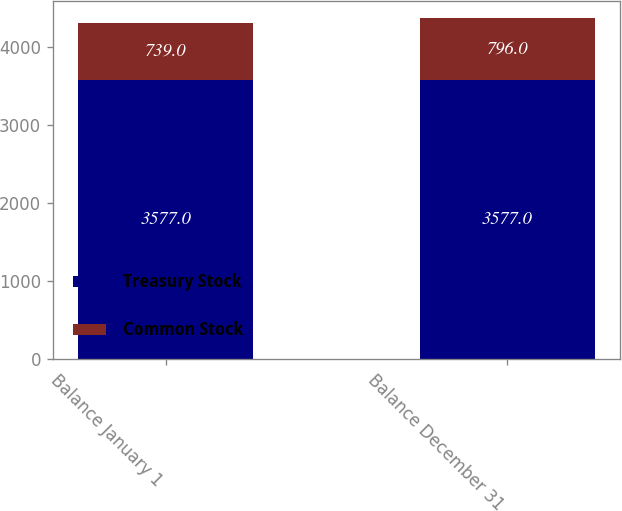<chart> <loc_0><loc_0><loc_500><loc_500><stacked_bar_chart><ecel><fcel>Balance January 1<fcel>Balance December 31<nl><fcel>Treasury Stock<fcel>3577<fcel>3577<nl><fcel>Common Stock<fcel>739<fcel>796<nl></chart> 